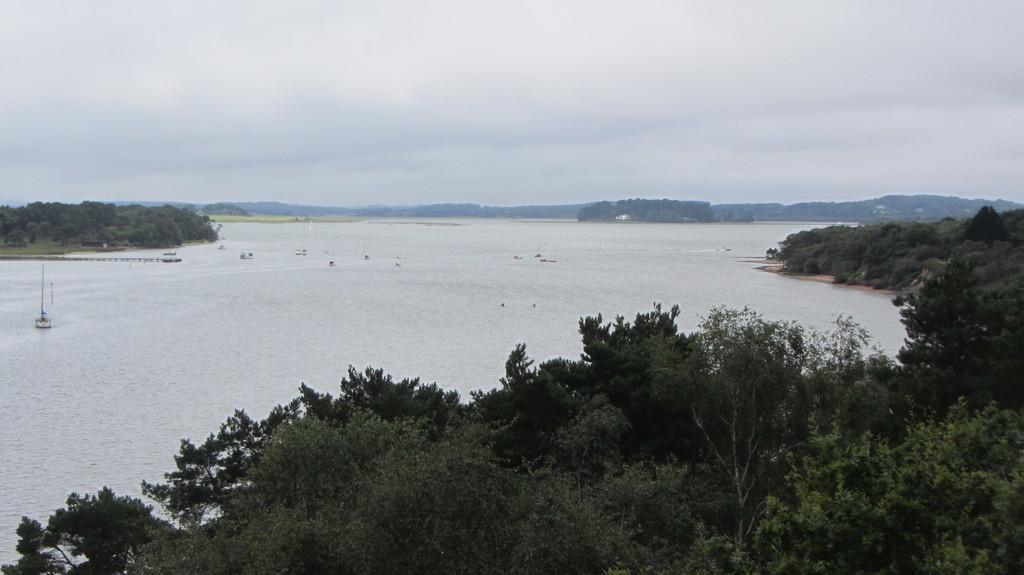How would you summarize this image in a sentence or two? In this image we can see the trees. And we can see the boats in the water. And we can see the clouds in the sky. And we can see the hill. 